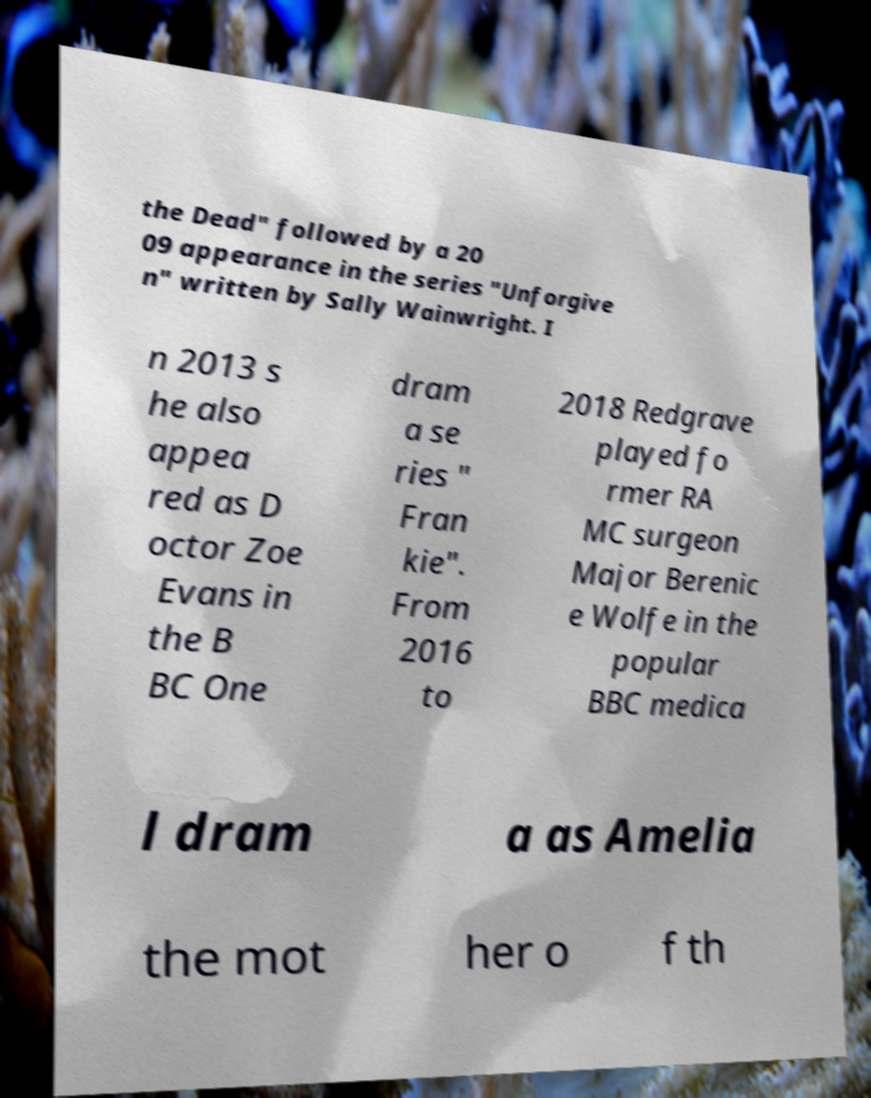Can you accurately transcribe the text from the provided image for me? the Dead" followed by a 20 09 appearance in the series "Unforgive n" written by Sally Wainwright. I n 2013 s he also appea red as D octor Zoe Evans in the B BC One dram a se ries " Fran kie". From 2016 to 2018 Redgrave played fo rmer RA MC surgeon Major Berenic e Wolfe in the popular BBC medica l dram a as Amelia the mot her o f th 